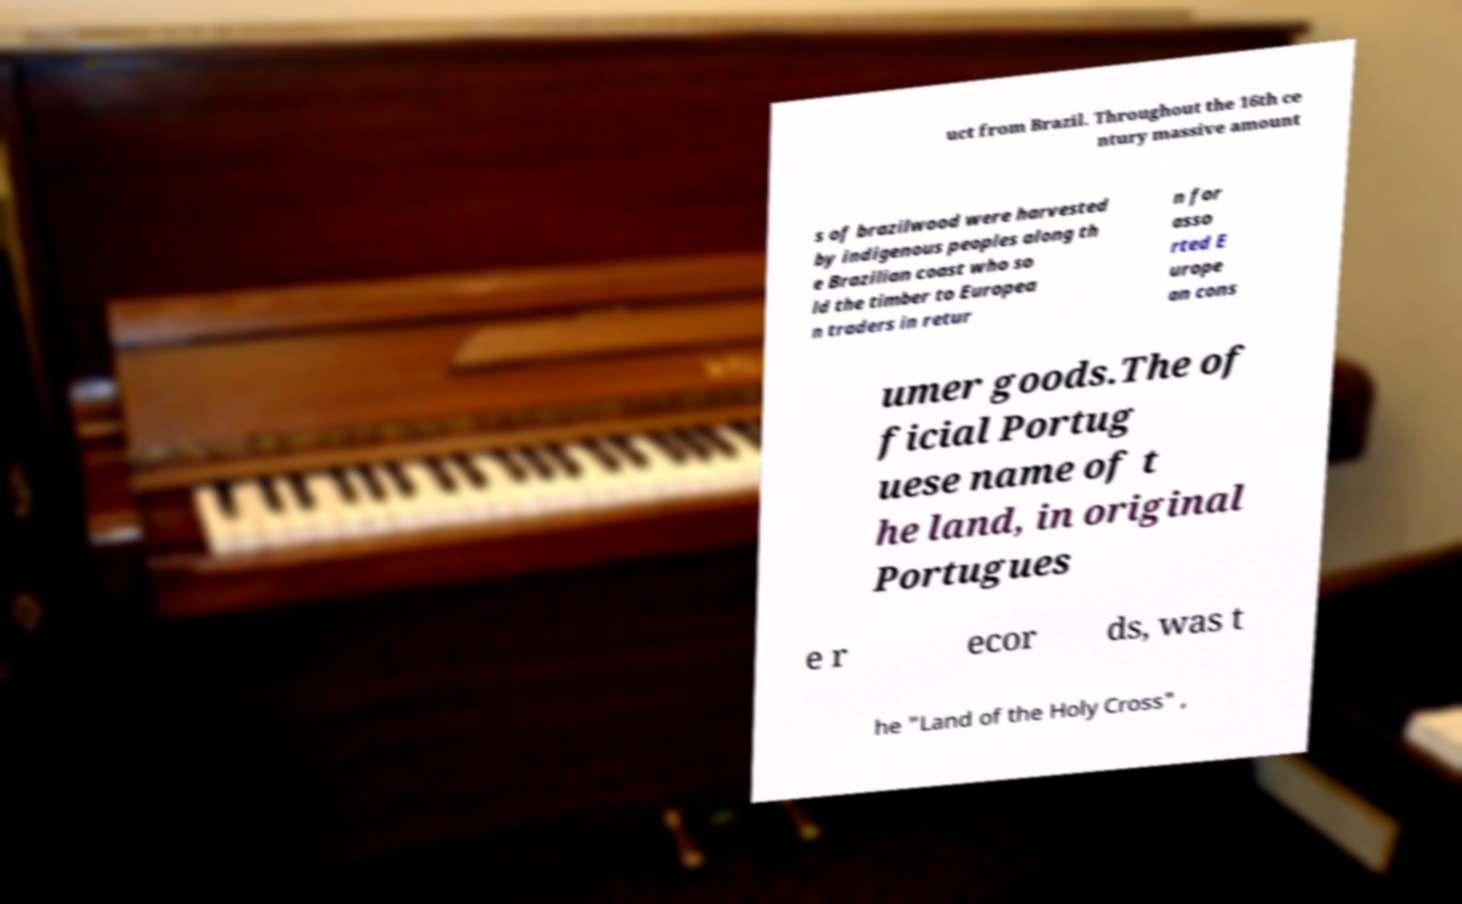Can you accurately transcribe the text from the provided image for me? uct from Brazil. Throughout the 16th ce ntury massive amount s of brazilwood were harvested by indigenous peoples along th e Brazilian coast who so ld the timber to Europea n traders in retur n for asso rted E urope an cons umer goods.The of ficial Portug uese name of t he land, in original Portugues e r ecor ds, was t he "Land of the Holy Cross" , 